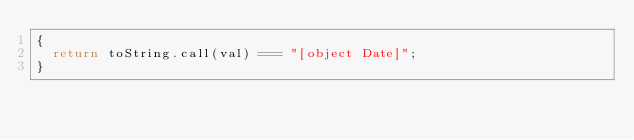<code> <loc_0><loc_0><loc_500><loc_500><_JavaScript_>{
  return toString.call(val) === "[object Date]";
}
</code> 